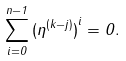Convert formula to latex. <formula><loc_0><loc_0><loc_500><loc_500>\sum _ { i = 0 } ^ { n - 1 } { ( \eta ^ { ( k - j ) } ) } ^ { i } = 0 .</formula> 